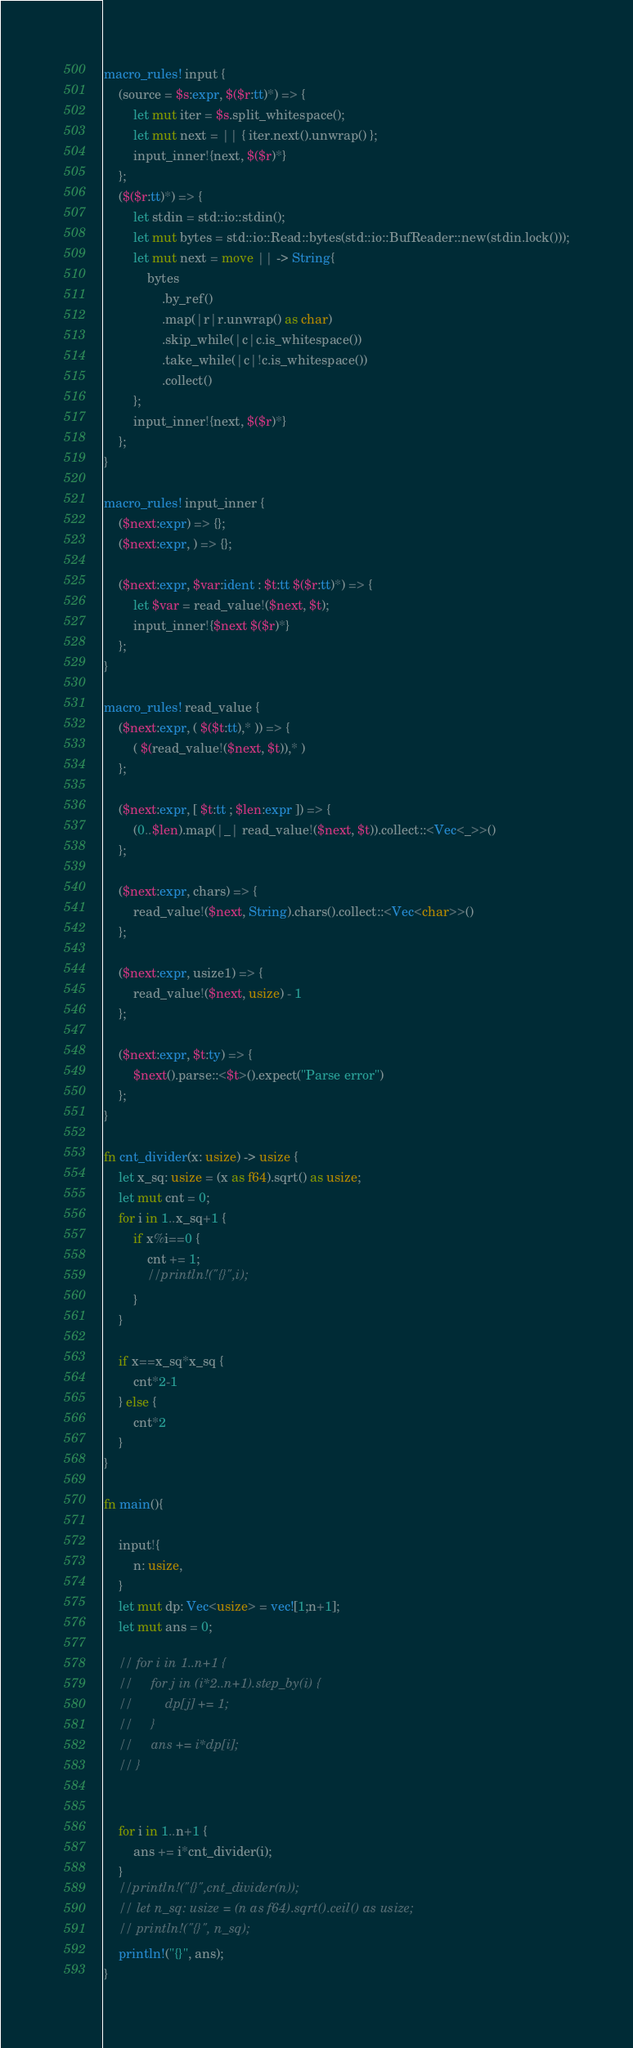Convert code to text. <code><loc_0><loc_0><loc_500><loc_500><_Rust_>macro_rules! input {
    (source = $s:expr, $($r:tt)*) => {
        let mut iter = $s.split_whitespace();
        let mut next = || { iter.next().unwrap() };
        input_inner!{next, $($r)*}
    };
    ($($r:tt)*) => {
        let stdin = std::io::stdin();
        let mut bytes = std::io::Read::bytes(std::io::BufReader::new(stdin.lock()));
        let mut next = move || -> String{
            bytes
                .by_ref()
                .map(|r|r.unwrap() as char)
                .skip_while(|c|c.is_whitespace())
                .take_while(|c|!c.is_whitespace())
                .collect()
        };
        input_inner!{next, $($r)*}
    };
}

macro_rules! input_inner {
    ($next:expr) => {};
    ($next:expr, ) => {};

    ($next:expr, $var:ident : $t:tt $($r:tt)*) => {
        let $var = read_value!($next, $t);
        input_inner!{$next $($r)*}
    };
}

macro_rules! read_value {
    ($next:expr, ( $($t:tt),* )) => {
        ( $(read_value!($next, $t)),* )
    };

    ($next:expr, [ $t:tt ; $len:expr ]) => {
        (0..$len).map(|_| read_value!($next, $t)).collect::<Vec<_>>()
    };

    ($next:expr, chars) => {
        read_value!($next, String).chars().collect::<Vec<char>>()
    };

    ($next:expr, usize1) => {
        read_value!($next, usize) - 1
    };

    ($next:expr, $t:ty) => {
        $next().parse::<$t>().expect("Parse error")
    };
}

fn cnt_divider(x: usize) -> usize {
    let x_sq: usize = (x as f64).sqrt() as usize;
    let mut cnt = 0;
    for i in 1..x_sq+1 {
        if x%i==0 {
            cnt += 1;
            //println!("{}",i);
        }
    }

    if x==x_sq*x_sq {
        cnt*2-1
    } else {
        cnt*2
    }
}

fn main(){

    input!{
        n: usize,
    }
    let mut dp: Vec<usize> = vec![1;n+1];
    let mut ans = 0;

    // for i in 1..n+1 {
    //     for j in (i*2..n+1).step_by(i) {
    //         dp[j] += 1;
    //     }
    //     ans += i*dp[i];
    // }


    for i in 1..n+1 {
        ans += i*cnt_divider(i);
    }
    //println!("{}",cnt_divider(n));
    // let n_sq: usize = (n as f64).sqrt().ceil() as usize;
    // println!("{}", n_sq);
    println!("{}", ans);
}</code> 